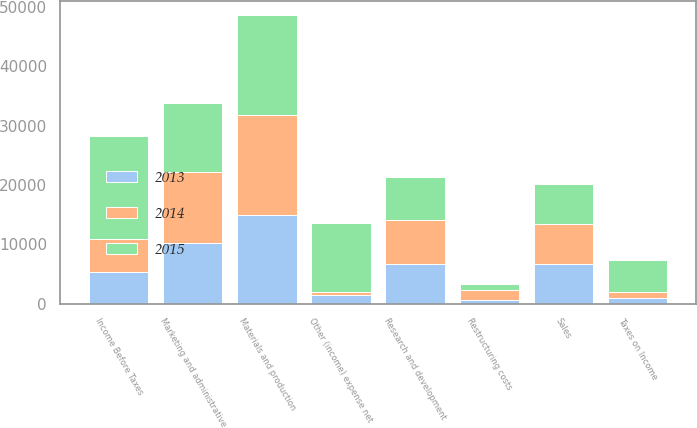Convert chart. <chart><loc_0><loc_0><loc_500><loc_500><stacked_bar_chart><ecel><fcel>Sales<fcel>Materials and production<fcel>Marketing and administrative<fcel>Research and development<fcel>Restructuring costs<fcel>Other (income) expense net<fcel>Income Before Taxes<fcel>Taxes on Income<nl><fcel>2013<fcel>6704<fcel>14934<fcel>10313<fcel>6704<fcel>619<fcel>1527<fcel>5401<fcel>942<nl><fcel>2015<fcel>6704<fcel>16768<fcel>11606<fcel>7180<fcel>1013<fcel>11613<fcel>17283<fcel>5349<nl><fcel>2014<fcel>6704<fcel>16954<fcel>11911<fcel>7503<fcel>1709<fcel>411<fcel>5545<fcel>1028<nl></chart> 